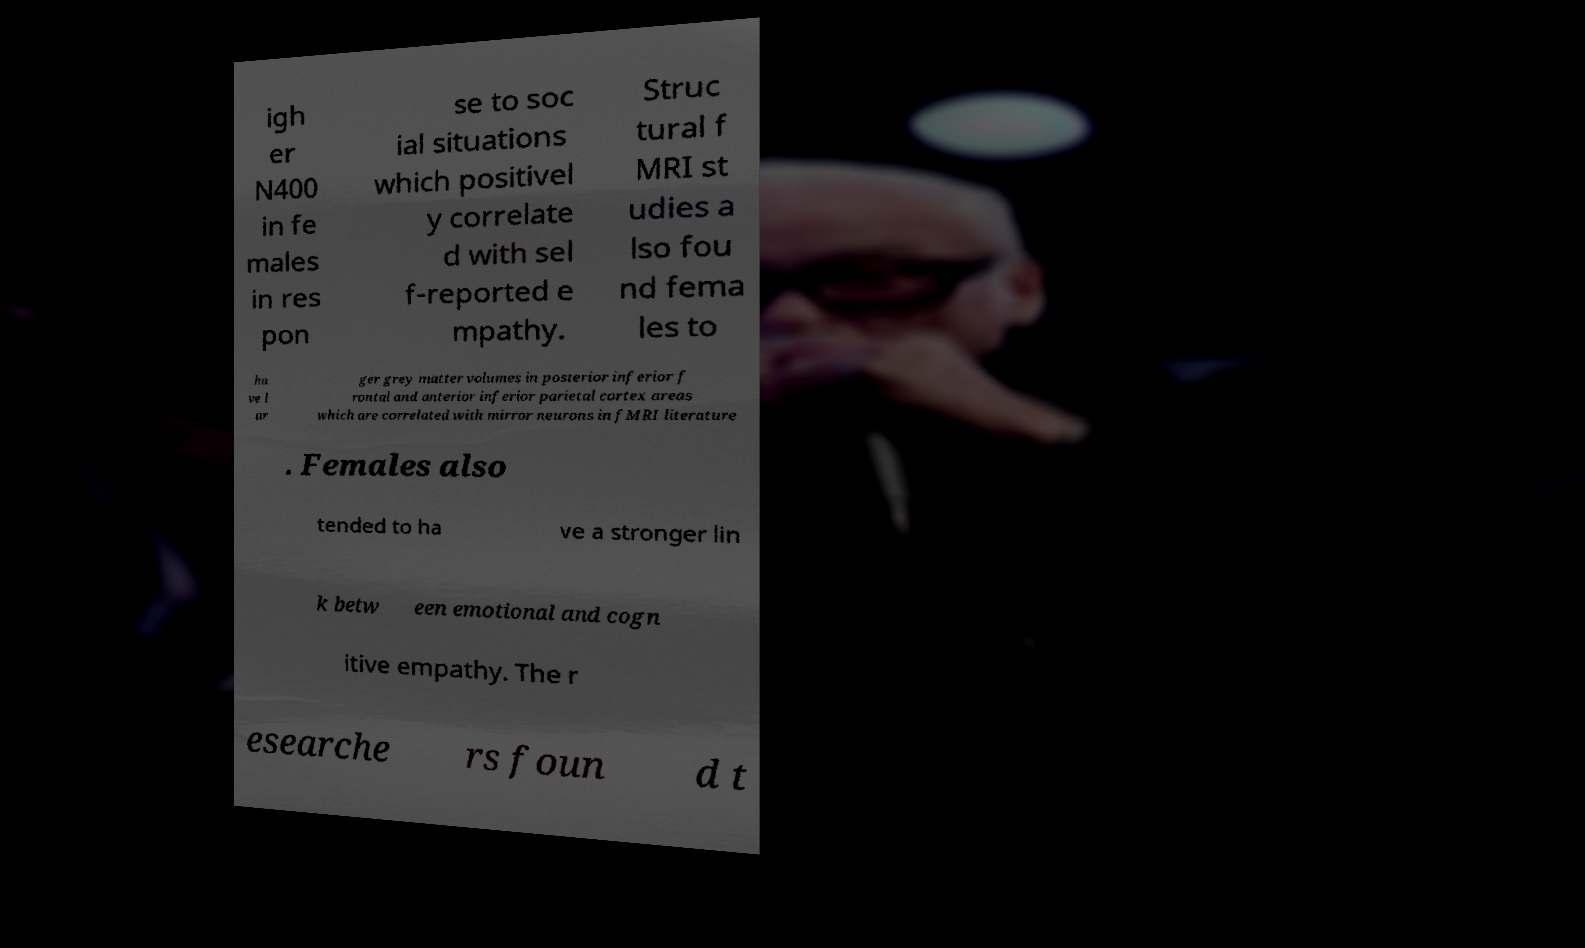Can you read and provide the text displayed in the image?This photo seems to have some interesting text. Can you extract and type it out for me? igh er N400 in fe males in res pon se to soc ial situations which positivel y correlate d with sel f-reported e mpathy. Struc tural f MRI st udies a lso fou nd fema les to ha ve l ar ger grey matter volumes in posterior inferior f rontal and anterior inferior parietal cortex areas which are correlated with mirror neurons in fMRI literature . Females also tended to ha ve a stronger lin k betw een emotional and cogn itive empathy. The r esearche rs foun d t 